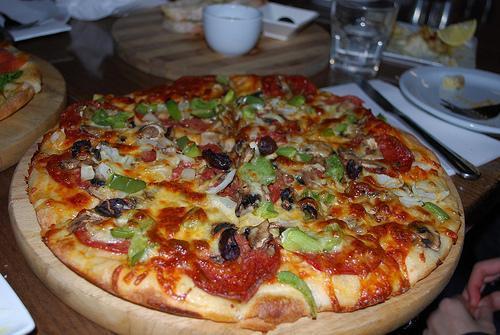How many people are shown?
Give a very brief answer. 1. 